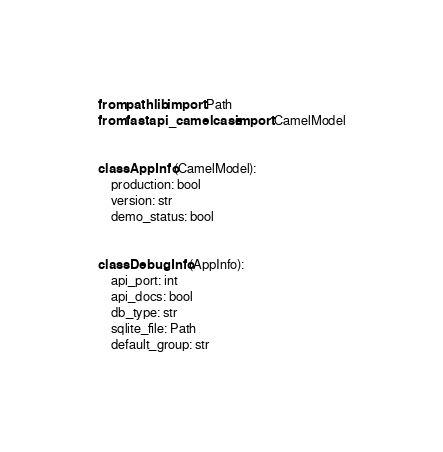Convert code to text. <code><loc_0><loc_0><loc_500><loc_500><_Python_>from pathlib import Path
from fastapi_camelcase import CamelModel


class AppInfo(CamelModel):
    production: bool
    version: str
    demo_status: bool


class DebugInfo(AppInfo):
    api_port: int
    api_docs: bool
    db_type: str
    sqlite_file: Path
    default_group: str
</code> 